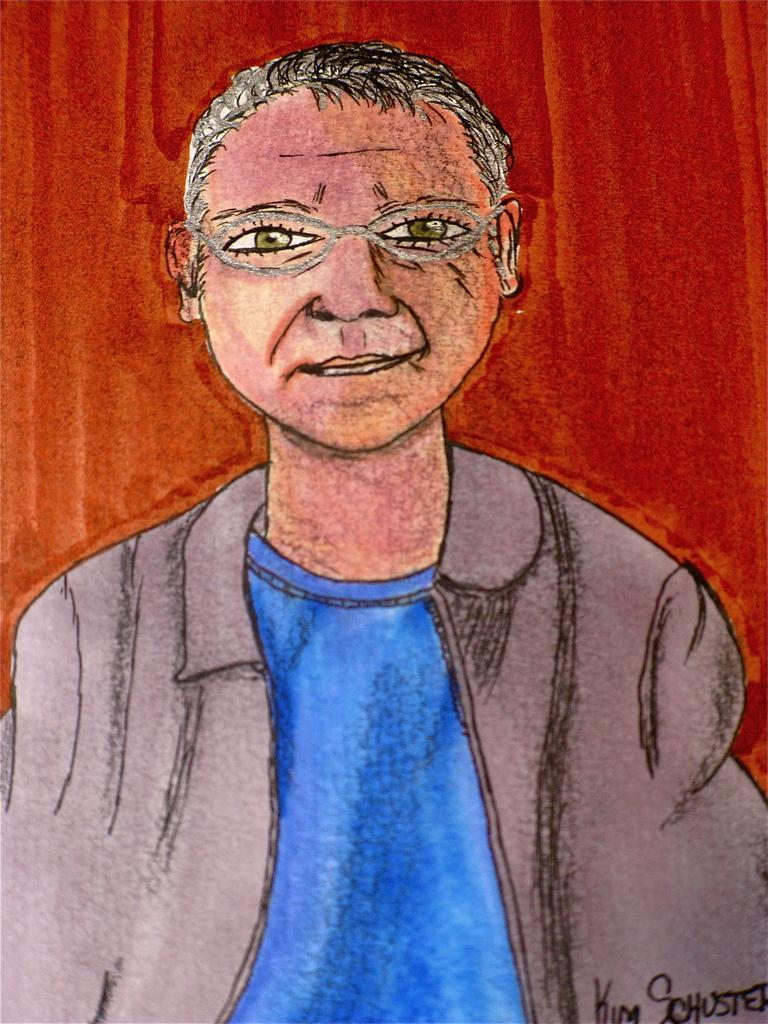What is depicted in the image? The image contains a sketch of a person. What is the person in the sketch wearing? The person in the sketch is wearing a jacket. What expression does the person in the sketch have? The person in the sketch is smiling. What color is the background of the sketch? The background of the sketch is in red color. Can you tell me how many lamps are visible in the sketch? There are no lamps present in the sketch; it is a sketch of a person with a red background. 